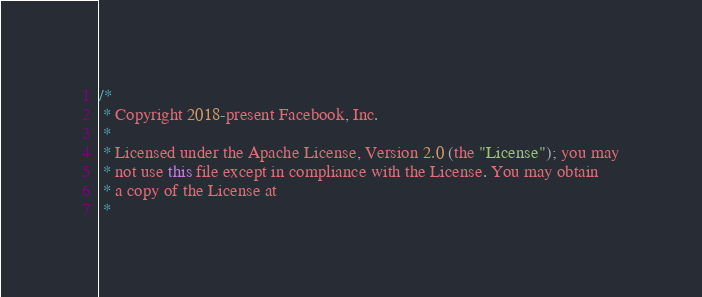Convert code to text. <code><loc_0><loc_0><loc_500><loc_500><_Java_>/*
 * Copyright 2018-present Facebook, Inc.
 *
 * Licensed under the Apache License, Version 2.0 (the "License"); you may
 * not use this file except in compliance with the License. You may obtain
 * a copy of the License at
 *</code> 